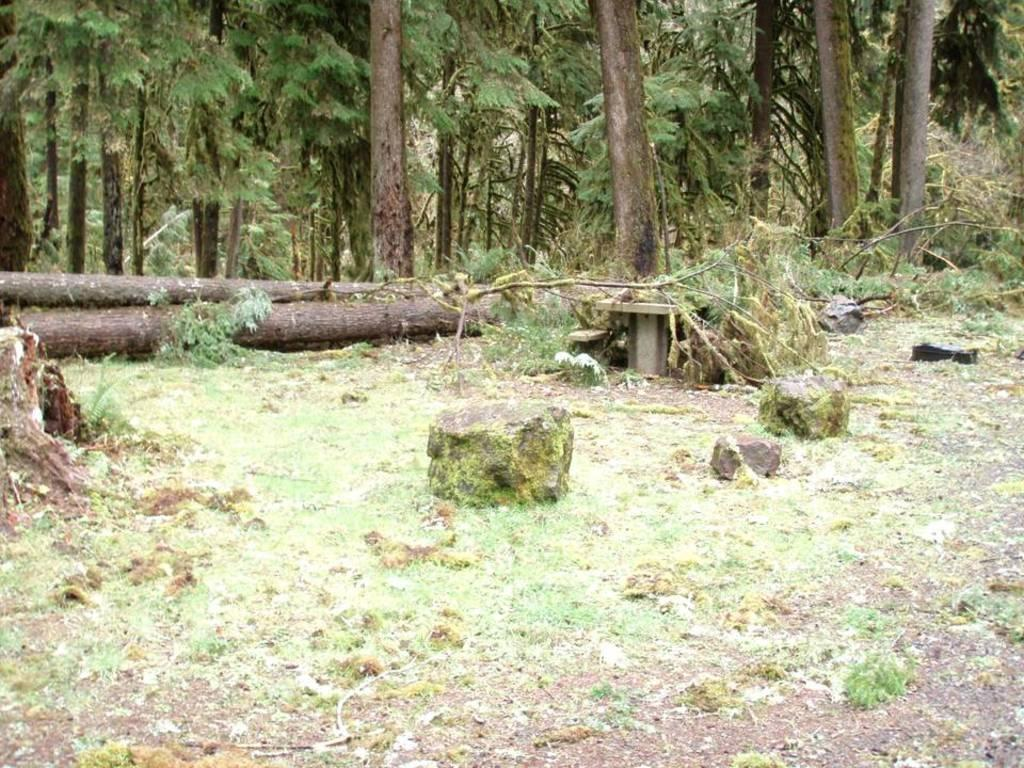What is located in the center of the image? There are rocks in the center of the image. What piece of furniture can be seen in the image? A bench is placed on the ground in the image. What type of natural elements are visible in the background of the image? There are wood logs and a group of trees in the background of the image. How many pins are holding the rocks together in the image? There are no pins present in the image; the rocks are not held together by any pins. Can you see any icicles hanging from the trees in the image? There are no icicles visible in the image; the trees are not covered in ice. 